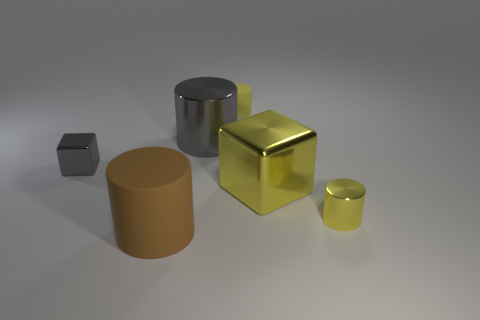How does the presence of multiple geometric shapes contribute to the composition of the image? The various geometric shapes in the image, including cylinders, cubes, and a small square block, provide a sense of balance and contrast that creates visual interest. The arrangement of these shapes in different sizes and colors highlights the diversity of forms and leads our eyes across the composition, inviting us to compare and contemplate the spatial relationships between them. 